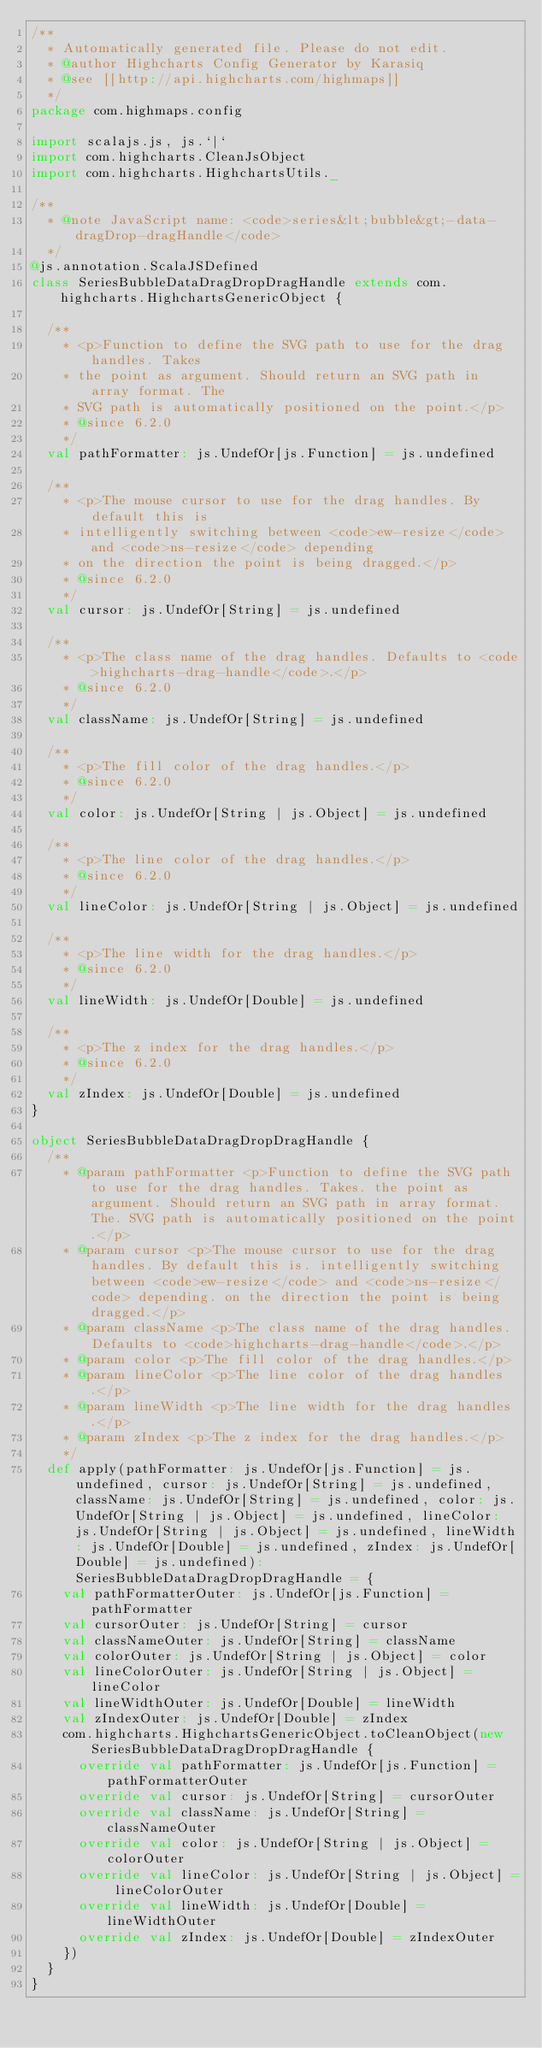Convert code to text. <code><loc_0><loc_0><loc_500><loc_500><_Scala_>/**
  * Automatically generated file. Please do not edit.
  * @author Highcharts Config Generator by Karasiq
  * @see [[http://api.highcharts.com/highmaps]]
  */
package com.highmaps.config

import scalajs.js, js.`|`
import com.highcharts.CleanJsObject
import com.highcharts.HighchartsUtils._

/**
  * @note JavaScript name: <code>series&lt;bubble&gt;-data-dragDrop-dragHandle</code>
  */
@js.annotation.ScalaJSDefined
class SeriesBubbleDataDragDropDragHandle extends com.highcharts.HighchartsGenericObject {

  /**
    * <p>Function to define the SVG path to use for the drag handles. Takes
    * the point as argument. Should return an SVG path in array format. The
    * SVG path is automatically positioned on the point.</p>
    * @since 6.2.0
    */
  val pathFormatter: js.UndefOr[js.Function] = js.undefined

  /**
    * <p>The mouse cursor to use for the drag handles. By default this is
    * intelligently switching between <code>ew-resize</code> and <code>ns-resize</code> depending
    * on the direction the point is being dragged.</p>
    * @since 6.2.0
    */
  val cursor: js.UndefOr[String] = js.undefined

  /**
    * <p>The class name of the drag handles. Defaults to <code>highcharts-drag-handle</code>.</p>
    * @since 6.2.0
    */
  val className: js.UndefOr[String] = js.undefined

  /**
    * <p>The fill color of the drag handles.</p>
    * @since 6.2.0
    */
  val color: js.UndefOr[String | js.Object] = js.undefined

  /**
    * <p>The line color of the drag handles.</p>
    * @since 6.2.0
    */
  val lineColor: js.UndefOr[String | js.Object] = js.undefined

  /**
    * <p>The line width for the drag handles.</p>
    * @since 6.2.0
    */
  val lineWidth: js.UndefOr[Double] = js.undefined

  /**
    * <p>The z index for the drag handles.</p>
    * @since 6.2.0
    */
  val zIndex: js.UndefOr[Double] = js.undefined
}

object SeriesBubbleDataDragDropDragHandle {
  /**
    * @param pathFormatter <p>Function to define the SVG path to use for the drag handles. Takes. the point as argument. Should return an SVG path in array format. The. SVG path is automatically positioned on the point.</p>
    * @param cursor <p>The mouse cursor to use for the drag handles. By default this is. intelligently switching between <code>ew-resize</code> and <code>ns-resize</code> depending. on the direction the point is being dragged.</p>
    * @param className <p>The class name of the drag handles. Defaults to <code>highcharts-drag-handle</code>.</p>
    * @param color <p>The fill color of the drag handles.</p>
    * @param lineColor <p>The line color of the drag handles.</p>
    * @param lineWidth <p>The line width for the drag handles.</p>
    * @param zIndex <p>The z index for the drag handles.</p>
    */
  def apply(pathFormatter: js.UndefOr[js.Function] = js.undefined, cursor: js.UndefOr[String] = js.undefined, className: js.UndefOr[String] = js.undefined, color: js.UndefOr[String | js.Object] = js.undefined, lineColor: js.UndefOr[String | js.Object] = js.undefined, lineWidth: js.UndefOr[Double] = js.undefined, zIndex: js.UndefOr[Double] = js.undefined): SeriesBubbleDataDragDropDragHandle = {
    val pathFormatterOuter: js.UndefOr[js.Function] = pathFormatter
    val cursorOuter: js.UndefOr[String] = cursor
    val classNameOuter: js.UndefOr[String] = className
    val colorOuter: js.UndefOr[String | js.Object] = color
    val lineColorOuter: js.UndefOr[String | js.Object] = lineColor
    val lineWidthOuter: js.UndefOr[Double] = lineWidth
    val zIndexOuter: js.UndefOr[Double] = zIndex
    com.highcharts.HighchartsGenericObject.toCleanObject(new SeriesBubbleDataDragDropDragHandle {
      override val pathFormatter: js.UndefOr[js.Function] = pathFormatterOuter
      override val cursor: js.UndefOr[String] = cursorOuter
      override val className: js.UndefOr[String] = classNameOuter
      override val color: js.UndefOr[String | js.Object] = colorOuter
      override val lineColor: js.UndefOr[String | js.Object] = lineColorOuter
      override val lineWidth: js.UndefOr[Double] = lineWidthOuter
      override val zIndex: js.UndefOr[Double] = zIndexOuter
    })
  }
}
</code> 